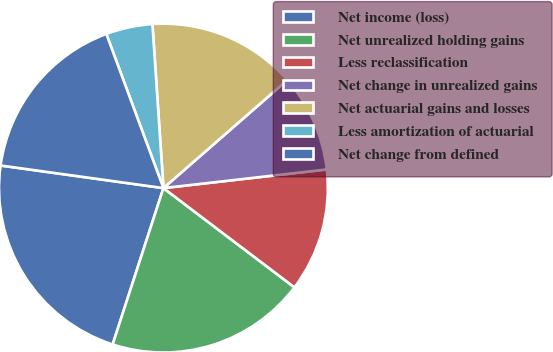Convert chart. <chart><loc_0><loc_0><loc_500><loc_500><pie_chart><fcel>Net income (loss)<fcel>Net unrealized holding gains<fcel>Less reclassification<fcel>Net change in unrealized gains<fcel>Net actuarial gains and losses<fcel>Less amortization of actuarial<fcel>Net change from defined<nl><fcel>22.2%<fcel>19.68%<fcel>12.13%<fcel>9.61%<fcel>14.65%<fcel>4.58%<fcel>17.16%<nl></chart> 